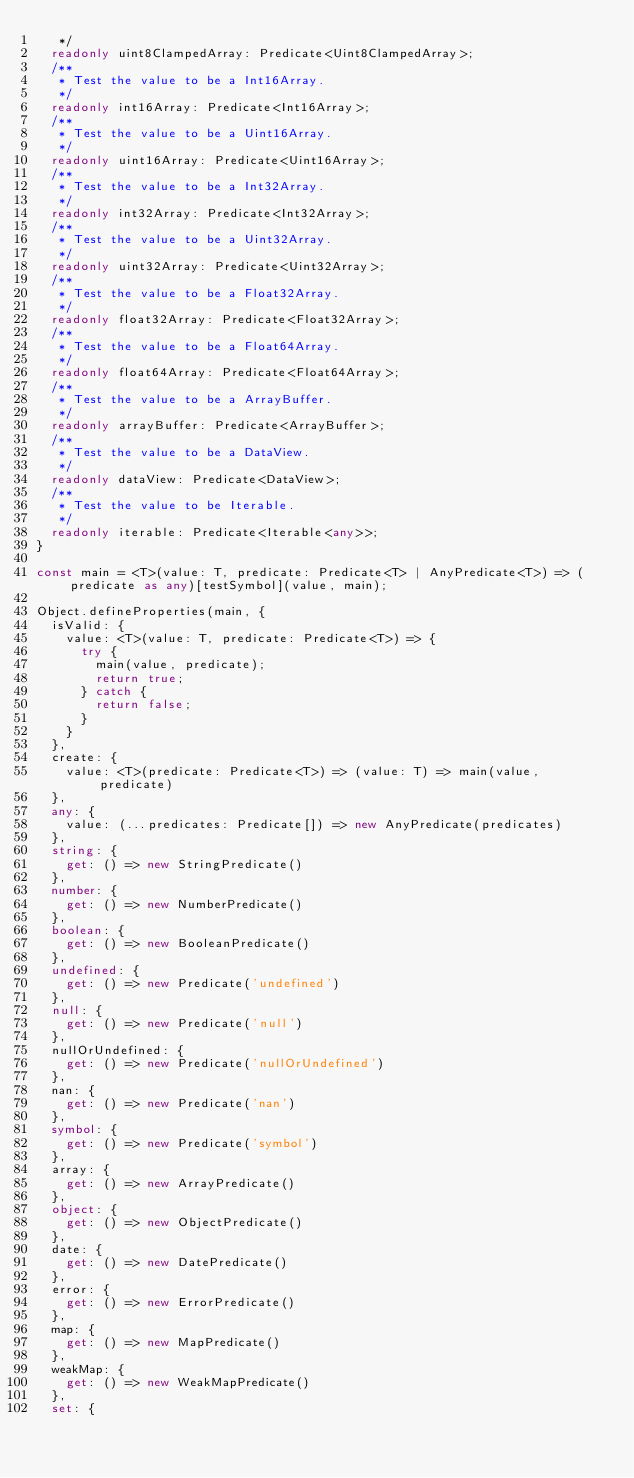Convert code to text. <code><loc_0><loc_0><loc_500><loc_500><_TypeScript_>	 */
	readonly uint8ClampedArray: Predicate<Uint8ClampedArray>;
	/**
	 * Test the value to be a Int16Array.
	 */
	readonly int16Array: Predicate<Int16Array>;
	/**
	 * Test the value to be a Uint16Array.
	 */
	readonly uint16Array: Predicate<Uint16Array>;
	/**
	 * Test the value to be a Int32Array.
	 */
	readonly int32Array: Predicate<Int32Array>;
	/**
	 * Test the value to be a Uint32Array.
	 */
	readonly uint32Array: Predicate<Uint32Array>;
	/**
	 * Test the value to be a Float32Array.
	 */
	readonly float32Array: Predicate<Float32Array>;
	/**
	 * Test the value to be a Float64Array.
	 */
	readonly float64Array: Predicate<Float64Array>;
	/**
	 * Test the value to be a ArrayBuffer.
	 */
	readonly arrayBuffer: Predicate<ArrayBuffer>;
	/**
	 * Test the value to be a DataView.
	 */
	readonly dataView: Predicate<DataView>;
	/**
	 * Test the value to be Iterable.
	 */
	readonly iterable: Predicate<Iterable<any>>;
}

const main = <T>(value: T, predicate: Predicate<T> | AnyPredicate<T>) => (predicate as any)[testSymbol](value, main);

Object.defineProperties(main, {
	isValid: {
		value: <T>(value: T, predicate: Predicate<T>) => {
			try {
				main(value, predicate);
				return true;
			} catch {
				return false;
			}
		}
	},
	create: {
		value: <T>(predicate: Predicate<T>) => (value: T) => main(value, predicate)
	},
	any: {
		value: (...predicates: Predicate[]) => new AnyPredicate(predicates)
	},
	string: {
		get: () => new StringPredicate()
	},
	number: {
		get: () => new NumberPredicate()
	},
	boolean: {
		get: () => new BooleanPredicate()
	},
	undefined: {
		get: () => new Predicate('undefined')
	},
	null: {
		get: () => new Predicate('null')
	},
	nullOrUndefined: {
		get: () => new Predicate('nullOrUndefined')
	},
	nan: {
		get: () => new Predicate('nan')
	},
	symbol: {
		get: () => new Predicate('symbol')
	},
	array: {
		get: () => new ArrayPredicate()
	},
	object: {
		get: () => new ObjectPredicate()
	},
	date: {
		get: () => new DatePredicate()
	},
	error: {
		get: () => new ErrorPredicate()
	},
	map: {
		get: () => new MapPredicate()
	},
	weakMap: {
		get: () => new WeakMapPredicate()
	},
	set: {</code> 